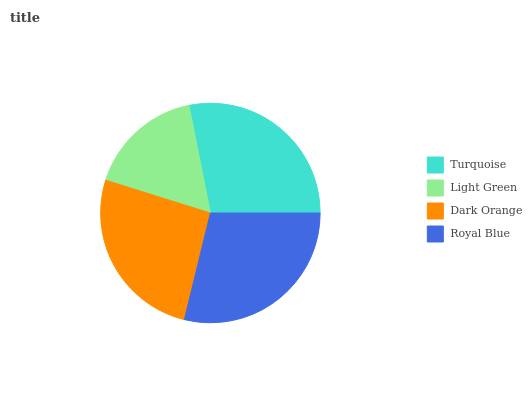Is Light Green the minimum?
Answer yes or no. Yes. Is Royal Blue the maximum?
Answer yes or no. Yes. Is Dark Orange the minimum?
Answer yes or no. No. Is Dark Orange the maximum?
Answer yes or no. No. Is Dark Orange greater than Light Green?
Answer yes or no. Yes. Is Light Green less than Dark Orange?
Answer yes or no. Yes. Is Light Green greater than Dark Orange?
Answer yes or no. No. Is Dark Orange less than Light Green?
Answer yes or no. No. Is Turquoise the high median?
Answer yes or no. Yes. Is Dark Orange the low median?
Answer yes or no. Yes. Is Light Green the high median?
Answer yes or no. No. Is Light Green the low median?
Answer yes or no. No. 